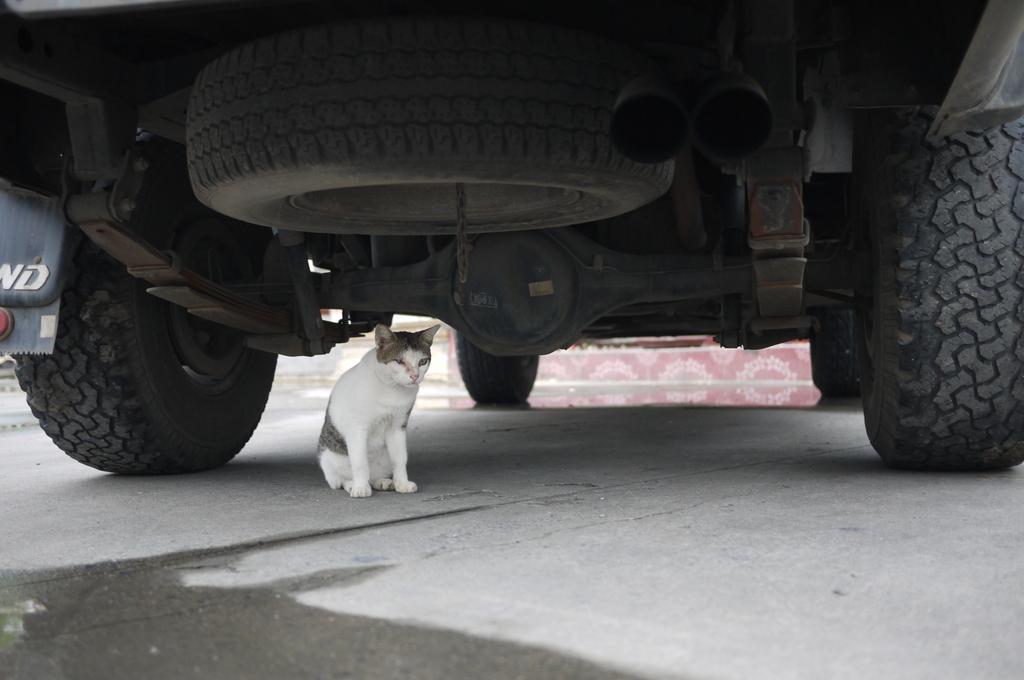Can you describe this image briefly? In the picture we can see under the vehicle with smoke pipe tire and tire which are fixed to the vehicle under it we can see a cat sitting on the path. 